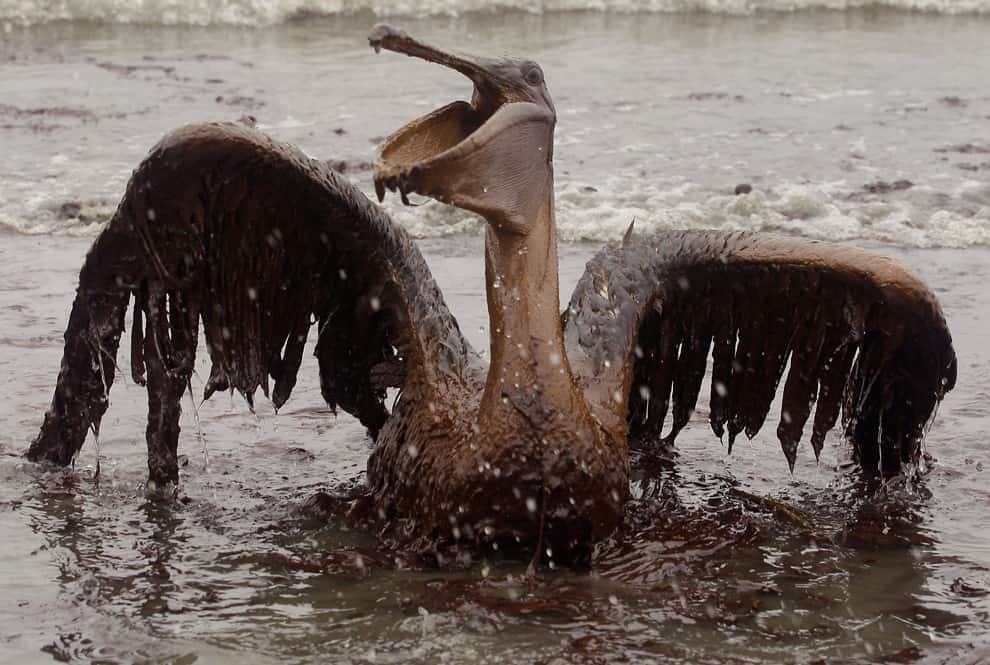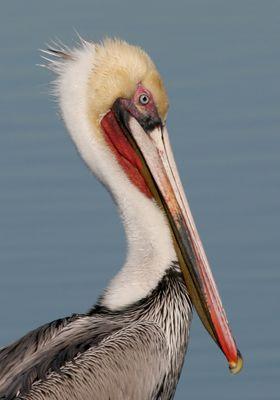The first image is the image on the left, the second image is the image on the right. Evaluate the accuracy of this statement regarding the images: "In one image, there is at least one person near a pelican.". Is it true? Answer yes or no. No. The first image is the image on the left, the second image is the image on the right. Examine the images to the left and right. Is the description "At least one person is interacting with birds in one image." accurate? Answer yes or no. No. 